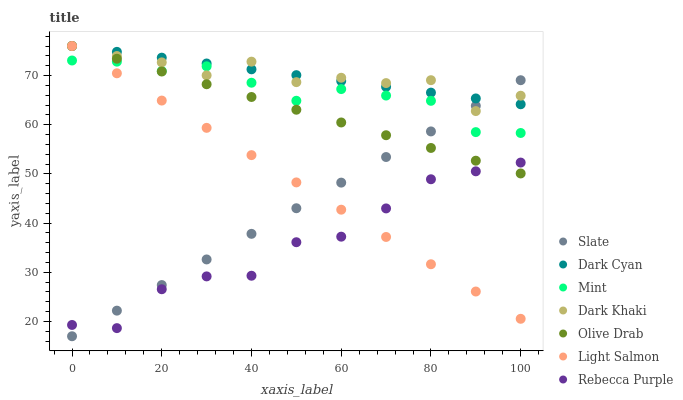Does Rebecca Purple have the minimum area under the curve?
Answer yes or no. Yes. Does Dark Cyan have the maximum area under the curve?
Answer yes or no. Yes. Does Slate have the minimum area under the curve?
Answer yes or no. No. Does Slate have the maximum area under the curve?
Answer yes or no. No. Is Slate the smoothest?
Answer yes or no. Yes. Is Dark Khaki the roughest?
Answer yes or no. Yes. Is Dark Khaki the smoothest?
Answer yes or no. No. Is Slate the roughest?
Answer yes or no. No. Does Slate have the lowest value?
Answer yes or no. Yes. Does Dark Khaki have the lowest value?
Answer yes or no. No. Does Olive Drab have the highest value?
Answer yes or no. Yes. Does Slate have the highest value?
Answer yes or no. No. Is Mint less than Dark Cyan?
Answer yes or no. Yes. Is Mint greater than Rebecca Purple?
Answer yes or no. Yes. Does Light Salmon intersect Olive Drab?
Answer yes or no. Yes. Is Light Salmon less than Olive Drab?
Answer yes or no. No. Is Light Salmon greater than Olive Drab?
Answer yes or no. No. Does Mint intersect Dark Cyan?
Answer yes or no. No. 